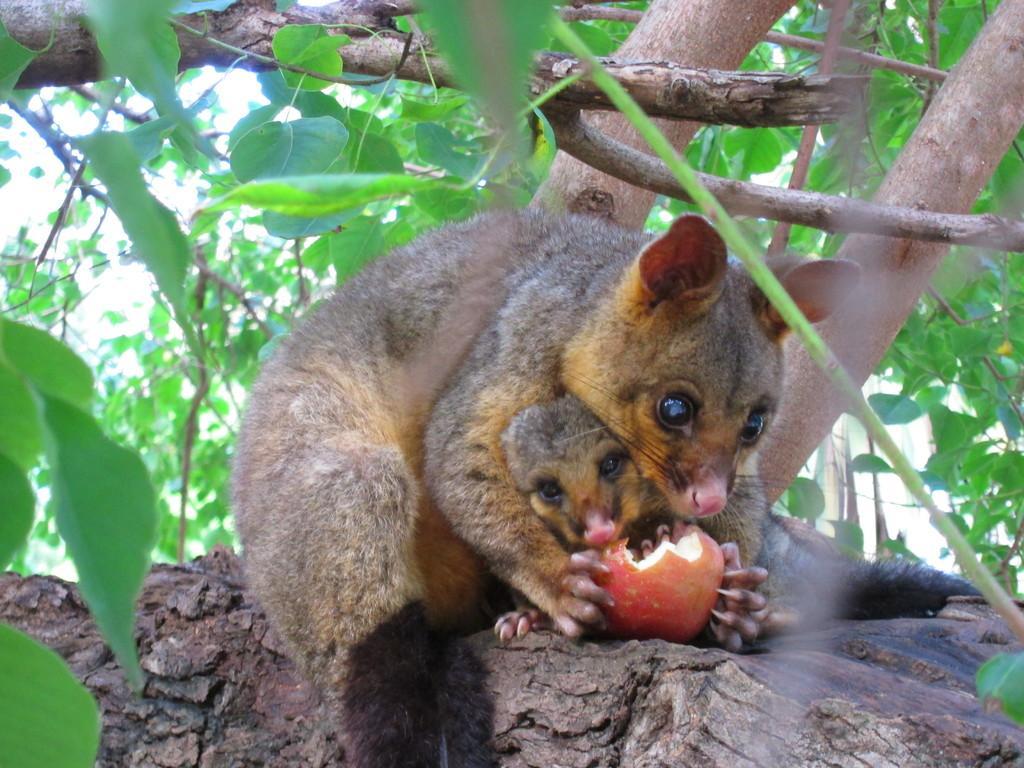Please provide a concise description of this image. This picture shows a fox squirrel and a baby fox squirrel on the tree. it is holding a fruit and we see leaves. it is a black and brown in color. 